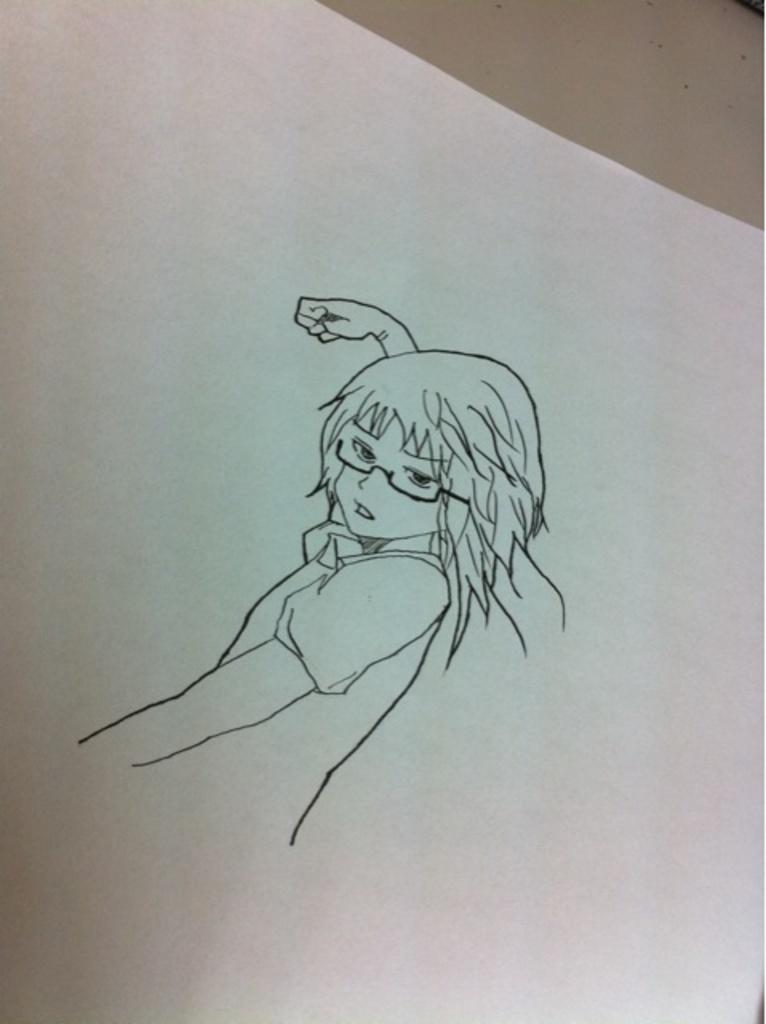What is depicted in the image? There is a sketch in the image. What is the subject of the sketch? The sketch is of a woman. On what surface is the sketch drawn? The sketch is on a paper. How many eggs are present in the image? There are no eggs present in the image; it features a sketch of a woman on a paper. What type of car is shown in the image? There is no car present in the image; it features a sketch of a woman on a paper. 